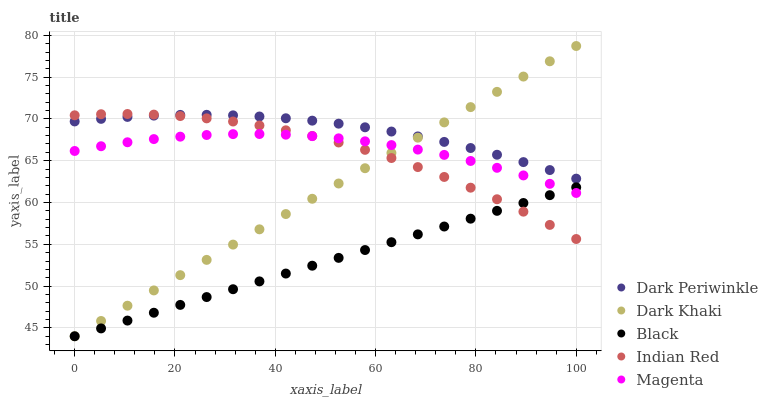Does Black have the minimum area under the curve?
Answer yes or no. Yes. Does Dark Periwinkle have the maximum area under the curve?
Answer yes or no. Yes. Does Magenta have the minimum area under the curve?
Answer yes or no. No. Does Magenta have the maximum area under the curve?
Answer yes or no. No. Is Black the smoothest?
Answer yes or no. Yes. Is Indian Red the roughest?
Answer yes or no. Yes. Is Magenta the smoothest?
Answer yes or no. No. Is Magenta the roughest?
Answer yes or no. No. Does Dark Khaki have the lowest value?
Answer yes or no. Yes. Does Magenta have the lowest value?
Answer yes or no. No. Does Dark Khaki have the highest value?
Answer yes or no. Yes. Does Magenta have the highest value?
Answer yes or no. No. Is Magenta less than Dark Periwinkle?
Answer yes or no. Yes. Is Dark Periwinkle greater than Black?
Answer yes or no. Yes. Does Magenta intersect Dark Khaki?
Answer yes or no. Yes. Is Magenta less than Dark Khaki?
Answer yes or no. No. Is Magenta greater than Dark Khaki?
Answer yes or no. No. Does Magenta intersect Dark Periwinkle?
Answer yes or no. No. 